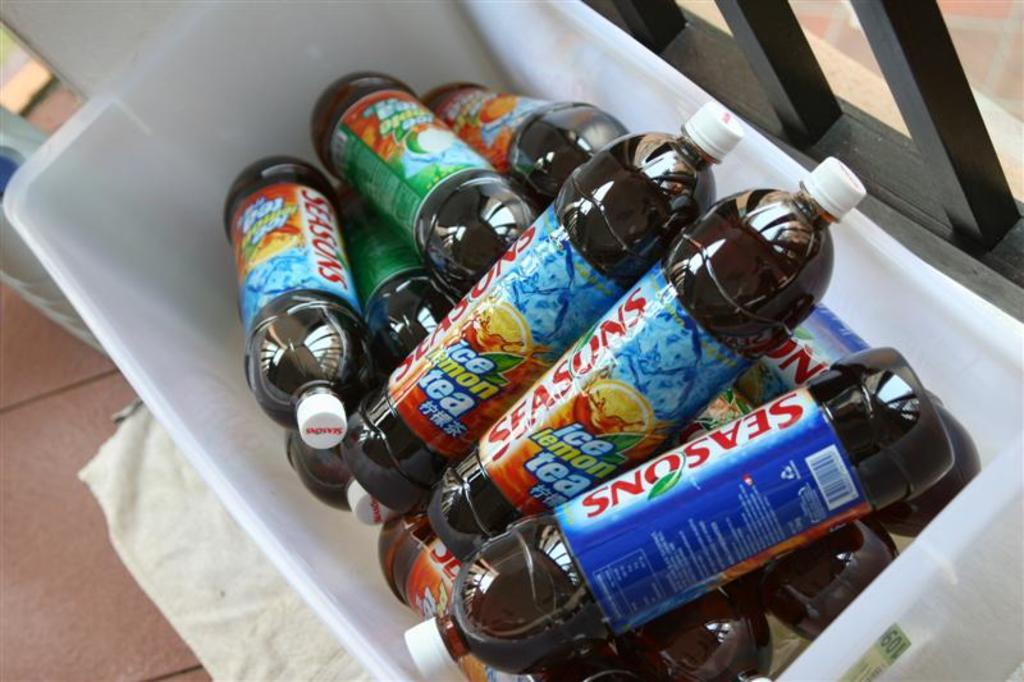<image>
Relay a brief, clear account of the picture shown. Bottles of ice lemon tea are in a bin. 